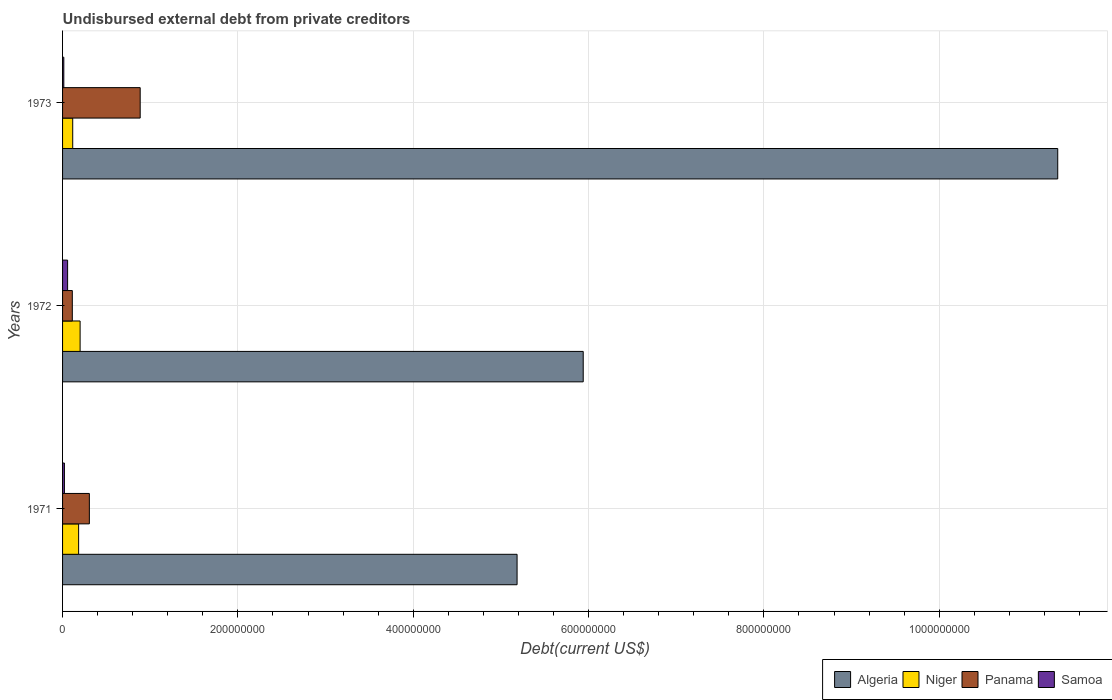How many different coloured bars are there?
Provide a succinct answer. 4. Are the number of bars per tick equal to the number of legend labels?
Your answer should be very brief. Yes. Are the number of bars on each tick of the Y-axis equal?
Your answer should be compact. Yes. What is the total debt in Niger in 1973?
Ensure brevity in your answer.  1.16e+07. Across all years, what is the maximum total debt in Samoa?
Your response must be concise. 5.75e+06. Across all years, what is the minimum total debt in Samoa?
Ensure brevity in your answer.  1.41e+06. In which year was the total debt in Panama maximum?
Offer a terse response. 1973. In which year was the total debt in Niger minimum?
Ensure brevity in your answer.  1973. What is the total total debt in Panama in the graph?
Give a very brief answer. 1.30e+08. What is the difference between the total debt in Algeria in 1971 and that in 1972?
Offer a very short reply. -7.55e+07. What is the difference between the total debt in Algeria in 1973 and the total debt in Panama in 1972?
Give a very brief answer. 1.12e+09. What is the average total debt in Niger per year?
Give a very brief answer. 1.66e+07. In the year 1972, what is the difference between the total debt in Niger and total debt in Algeria?
Make the answer very short. -5.74e+08. In how many years, is the total debt in Samoa greater than 440000000 US$?
Your answer should be compact. 0. What is the ratio of the total debt in Samoa in 1971 to that in 1972?
Provide a succinct answer. 0.37. Is the difference between the total debt in Niger in 1972 and 1973 greater than the difference between the total debt in Algeria in 1972 and 1973?
Keep it short and to the point. Yes. What is the difference between the highest and the second highest total debt in Panama?
Give a very brief answer. 5.80e+07. What is the difference between the highest and the lowest total debt in Algeria?
Make the answer very short. 6.17e+08. Is the sum of the total debt in Niger in 1971 and 1972 greater than the maximum total debt in Panama across all years?
Provide a short and direct response. No. Is it the case that in every year, the sum of the total debt in Algeria and total debt in Niger is greater than the sum of total debt in Panama and total debt in Samoa?
Your response must be concise. No. What does the 2nd bar from the top in 1972 represents?
Ensure brevity in your answer.  Panama. What does the 1st bar from the bottom in 1973 represents?
Provide a short and direct response. Algeria. Is it the case that in every year, the sum of the total debt in Panama and total debt in Algeria is greater than the total debt in Samoa?
Provide a short and direct response. Yes. How many bars are there?
Provide a short and direct response. 12. Are all the bars in the graph horizontal?
Offer a very short reply. Yes. How many years are there in the graph?
Make the answer very short. 3. Are the values on the major ticks of X-axis written in scientific E-notation?
Your answer should be very brief. No. Where does the legend appear in the graph?
Keep it short and to the point. Bottom right. What is the title of the graph?
Provide a succinct answer. Undisbursed external debt from private creditors. Does "Antigua and Barbuda" appear as one of the legend labels in the graph?
Keep it short and to the point. No. What is the label or title of the X-axis?
Provide a succinct answer. Debt(current US$). What is the Debt(current US$) in Algeria in 1971?
Offer a very short reply. 5.18e+08. What is the Debt(current US$) in Niger in 1971?
Your answer should be very brief. 1.83e+07. What is the Debt(current US$) in Panama in 1971?
Provide a short and direct response. 3.06e+07. What is the Debt(current US$) in Samoa in 1971?
Make the answer very short. 2.11e+06. What is the Debt(current US$) of Algeria in 1972?
Your response must be concise. 5.94e+08. What is the Debt(current US$) in Niger in 1972?
Your response must be concise. 2.00e+07. What is the Debt(current US$) in Panama in 1972?
Offer a very short reply. 1.11e+07. What is the Debt(current US$) in Samoa in 1972?
Your response must be concise. 5.75e+06. What is the Debt(current US$) of Algeria in 1973?
Keep it short and to the point. 1.14e+09. What is the Debt(current US$) of Niger in 1973?
Your answer should be very brief. 1.16e+07. What is the Debt(current US$) of Panama in 1973?
Your answer should be very brief. 8.85e+07. What is the Debt(current US$) of Samoa in 1973?
Ensure brevity in your answer.  1.41e+06. Across all years, what is the maximum Debt(current US$) of Algeria?
Give a very brief answer. 1.14e+09. Across all years, what is the maximum Debt(current US$) in Niger?
Ensure brevity in your answer.  2.00e+07. Across all years, what is the maximum Debt(current US$) in Panama?
Give a very brief answer. 8.85e+07. Across all years, what is the maximum Debt(current US$) in Samoa?
Provide a succinct answer. 5.75e+06. Across all years, what is the minimum Debt(current US$) in Algeria?
Offer a very short reply. 5.18e+08. Across all years, what is the minimum Debt(current US$) in Niger?
Offer a terse response. 1.16e+07. Across all years, what is the minimum Debt(current US$) in Panama?
Offer a terse response. 1.11e+07. Across all years, what is the minimum Debt(current US$) in Samoa?
Offer a very short reply. 1.41e+06. What is the total Debt(current US$) in Algeria in the graph?
Make the answer very short. 2.25e+09. What is the total Debt(current US$) in Niger in the graph?
Your response must be concise. 4.99e+07. What is the total Debt(current US$) in Panama in the graph?
Provide a succinct answer. 1.30e+08. What is the total Debt(current US$) of Samoa in the graph?
Your answer should be very brief. 9.27e+06. What is the difference between the Debt(current US$) in Algeria in 1971 and that in 1972?
Make the answer very short. -7.55e+07. What is the difference between the Debt(current US$) of Niger in 1971 and that in 1972?
Offer a terse response. -1.68e+06. What is the difference between the Debt(current US$) in Panama in 1971 and that in 1972?
Your answer should be very brief. 1.94e+07. What is the difference between the Debt(current US$) in Samoa in 1971 and that in 1972?
Keep it short and to the point. -3.63e+06. What is the difference between the Debt(current US$) in Algeria in 1971 and that in 1973?
Keep it short and to the point. -6.17e+08. What is the difference between the Debt(current US$) of Niger in 1971 and that in 1973?
Offer a terse response. 6.74e+06. What is the difference between the Debt(current US$) in Panama in 1971 and that in 1973?
Ensure brevity in your answer.  -5.80e+07. What is the difference between the Debt(current US$) of Samoa in 1971 and that in 1973?
Keep it short and to the point. 6.99e+05. What is the difference between the Debt(current US$) of Algeria in 1972 and that in 1973?
Offer a very short reply. -5.41e+08. What is the difference between the Debt(current US$) of Niger in 1972 and that in 1973?
Your answer should be very brief. 8.42e+06. What is the difference between the Debt(current US$) of Panama in 1972 and that in 1973?
Your response must be concise. -7.74e+07. What is the difference between the Debt(current US$) of Samoa in 1972 and that in 1973?
Provide a short and direct response. 4.33e+06. What is the difference between the Debt(current US$) of Algeria in 1971 and the Debt(current US$) of Niger in 1972?
Your answer should be very brief. 4.98e+08. What is the difference between the Debt(current US$) in Algeria in 1971 and the Debt(current US$) in Panama in 1972?
Provide a succinct answer. 5.07e+08. What is the difference between the Debt(current US$) of Algeria in 1971 and the Debt(current US$) of Samoa in 1972?
Your answer should be compact. 5.13e+08. What is the difference between the Debt(current US$) in Niger in 1971 and the Debt(current US$) in Panama in 1972?
Offer a terse response. 7.20e+06. What is the difference between the Debt(current US$) of Niger in 1971 and the Debt(current US$) of Samoa in 1972?
Make the answer very short. 1.26e+07. What is the difference between the Debt(current US$) in Panama in 1971 and the Debt(current US$) in Samoa in 1972?
Your answer should be very brief. 2.48e+07. What is the difference between the Debt(current US$) of Algeria in 1971 and the Debt(current US$) of Niger in 1973?
Offer a very short reply. 5.07e+08. What is the difference between the Debt(current US$) in Algeria in 1971 and the Debt(current US$) in Panama in 1973?
Provide a succinct answer. 4.30e+08. What is the difference between the Debt(current US$) of Algeria in 1971 and the Debt(current US$) of Samoa in 1973?
Your answer should be compact. 5.17e+08. What is the difference between the Debt(current US$) of Niger in 1971 and the Debt(current US$) of Panama in 1973?
Make the answer very short. -7.02e+07. What is the difference between the Debt(current US$) of Niger in 1971 and the Debt(current US$) of Samoa in 1973?
Provide a succinct answer. 1.69e+07. What is the difference between the Debt(current US$) in Panama in 1971 and the Debt(current US$) in Samoa in 1973?
Your response must be concise. 2.92e+07. What is the difference between the Debt(current US$) in Algeria in 1972 and the Debt(current US$) in Niger in 1973?
Give a very brief answer. 5.82e+08. What is the difference between the Debt(current US$) in Algeria in 1972 and the Debt(current US$) in Panama in 1973?
Keep it short and to the point. 5.05e+08. What is the difference between the Debt(current US$) of Algeria in 1972 and the Debt(current US$) of Samoa in 1973?
Your answer should be very brief. 5.93e+08. What is the difference between the Debt(current US$) of Niger in 1972 and the Debt(current US$) of Panama in 1973?
Offer a very short reply. -6.85e+07. What is the difference between the Debt(current US$) in Niger in 1972 and the Debt(current US$) in Samoa in 1973?
Provide a short and direct response. 1.86e+07. What is the difference between the Debt(current US$) in Panama in 1972 and the Debt(current US$) in Samoa in 1973?
Your answer should be compact. 9.70e+06. What is the average Debt(current US$) of Algeria per year?
Your answer should be very brief. 7.49e+08. What is the average Debt(current US$) in Niger per year?
Your answer should be very brief. 1.66e+07. What is the average Debt(current US$) of Panama per year?
Your answer should be compact. 4.34e+07. What is the average Debt(current US$) of Samoa per year?
Offer a very short reply. 3.09e+06. In the year 1971, what is the difference between the Debt(current US$) in Algeria and Debt(current US$) in Niger?
Offer a terse response. 5.00e+08. In the year 1971, what is the difference between the Debt(current US$) of Algeria and Debt(current US$) of Panama?
Keep it short and to the point. 4.88e+08. In the year 1971, what is the difference between the Debt(current US$) in Algeria and Debt(current US$) in Samoa?
Your answer should be very brief. 5.16e+08. In the year 1971, what is the difference between the Debt(current US$) in Niger and Debt(current US$) in Panama?
Ensure brevity in your answer.  -1.22e+07. In the year 1971, what is the difference between the Debt(current US$) of Niger and Debt(current US$) of Samoa?
Offer a very short reply. 1.62e+07. In the year 1971, what is the difference between the Debt(current US$) in Panama and Debt(current US$) in Samoa?
Provide a short and direct response. 2.85e+07. In the year 1972, what is the difference between the Debt(current US$) of Algeria and Debt(current US$) of Niger?
Ensure brevity in your answer.  5.74e+08. In the year 1972, what is the difference between the Debt(current US$) in Algeria and Debt(current US$) in Panama?
Provide a short and direct response. 5.83e+08. In the year 1972, what is the difference between the Debt(current US$) in Algeria and Debt(current US$) in Samoa?
Offer a terse response. 5.88e+08. In the year 1972, what is the difference between the Debt(current US$) in Niger and Debt(current US$) in Panama?
Your answer should be very brief. 8.89e+06. In the year 1972, what is the difference between the Debt(current US$) of Niger and Debt(current US$) of Samoa?
Give a very brief answer. 1.43e+07. In the year 1972, what is the difference between the Debt(current US$) in Panama and Debt(current US$) in Samoa?
Keep it short and to the point. 5.37e+06. In the year 1973, what is the difference between the Debt(current US$) of Algeria and Debt(current US$) of Niger?
Offer a terse response. 1.12e+09. In the year 1973, what is the difference between the Debt(current US$) in Algeria and Debt(current US$) in Panama?
Your response must be concise. 1.05e+09. In the year 1973, what is the difference between the Debt(current US$) in Algeria and Debt(current US$) in Samoa?
Ensure brevity in your answer.  1.13e+09. In the year 1973, what is the difference between the Debt(current US$) in Niger and Debt(current US$) in Panama?
Make the answer very short. -7.70e+07. In the year 1973, what is the difference between the Debt(current US$) of Niger and Debt(current US$) of Samoa?
Provide a succinct answer. 1.02e+07. In the year 1973, what is the difference between the Debt(current US$) of Panama and Debt(current US$) of Samoa?
Make the answer very short. 8.71e+07. What is the ratio of the Debt(current US$) in Algeria in 1971 to that in 1972?
Provide a short and direct response. 0.87. What is the ratio of the Debt(current US$) of Niger in 1971 to that in 1972?
Your response must be concise. 0.92. What is the ratio of the Debt(current US$) of Panama in 1971 to that in 1972?
Your answer should be compact. 2.75. What is the ratio of the Debt(current US$) of Samoa in 1971 to that in 1972?
Provide a short and direct response. 0.37. What is the ratio of the Debt(current US$) in Algeria in 1971 to that in 1973?
Give a very brief answer. 0.46. What is the ratio of the Debt(current US$) in Niger in 1971 to that in 1973?
Your answer should be very brief. 1.58. What is the ratio of the Debt(current US$) of Panama in 1971 to that in 1973?
Provide a short and direct response. 0.35. What is the ratio of the Debt(current US$) in Samoa in 1971 to that in 1973?
Ensure brevity in your answer.  1.49. What is the ratio of the Debt(current US$) of Algeria in 1972 to that in 1973?
Your answer should be compact. 0.52. What is the ratio of the Debt(current US$) in Niger in 1972 to that in 1973?
Provide a succinct answer. 1.73. What is the ratio of the Debt(current US$) in Panama in 1972 to that in 1973?
Your response must be concise. 0.13. What is the ratio of the Debt(current US$) of Samoa in 1972 to that in 1973?
Your answer should be compact. 4.06. What is the difference between the highest and the second highest Debt(current US$) of Algeria?
Ensure brevity in your answer.  5.41e+08. What is the difference between the highest and the second highest Debt(current US$) in Niger?
Offer a very short reply. 1.68e+06. What is the difference between the highest and the second highest Debt(current US$) of Panama?
Offer a terse response. 5.80e+07. What is the difference between the highest and the second highest Debt(current US$) of Samoa?
Offer a terse response. 3.63e+06. What is the difference between the highest and the lowest Debt(current US$) in Algeria?
Offer a terse response. 6.17e+08. What is the difference between the highest and the lowest Debt(current US$) in Niger?
Ensure brevity in your answer.  8.42e+06. What is the difference between the highest and the lowest Debt(current US$) of Panama?
Provide a short and direct response. 7.74e+07. What is the difference between the highest and the lowest Debt(current US$) of Samoa?
Your response must be concise. 4.33e+06. 